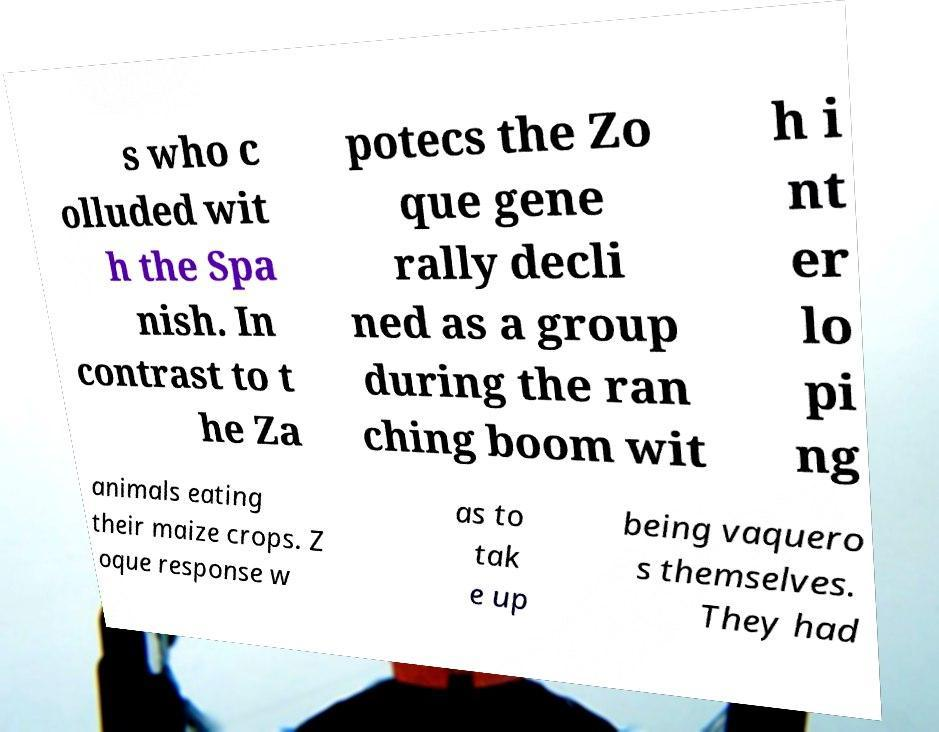Can you read and provide the text displayed in the image?This photo seems to have some interesting text. Can you extract and type it out for me? s who c olluded wit h the Spa nish. In contrast to t he Za potecs the Zo que gene rally decli ned as a group during the ran ching boom wit h i nt er lo pi ng animals eating their maize crops. Z oque response w as to tak e up being vaquero s themselves. They had 